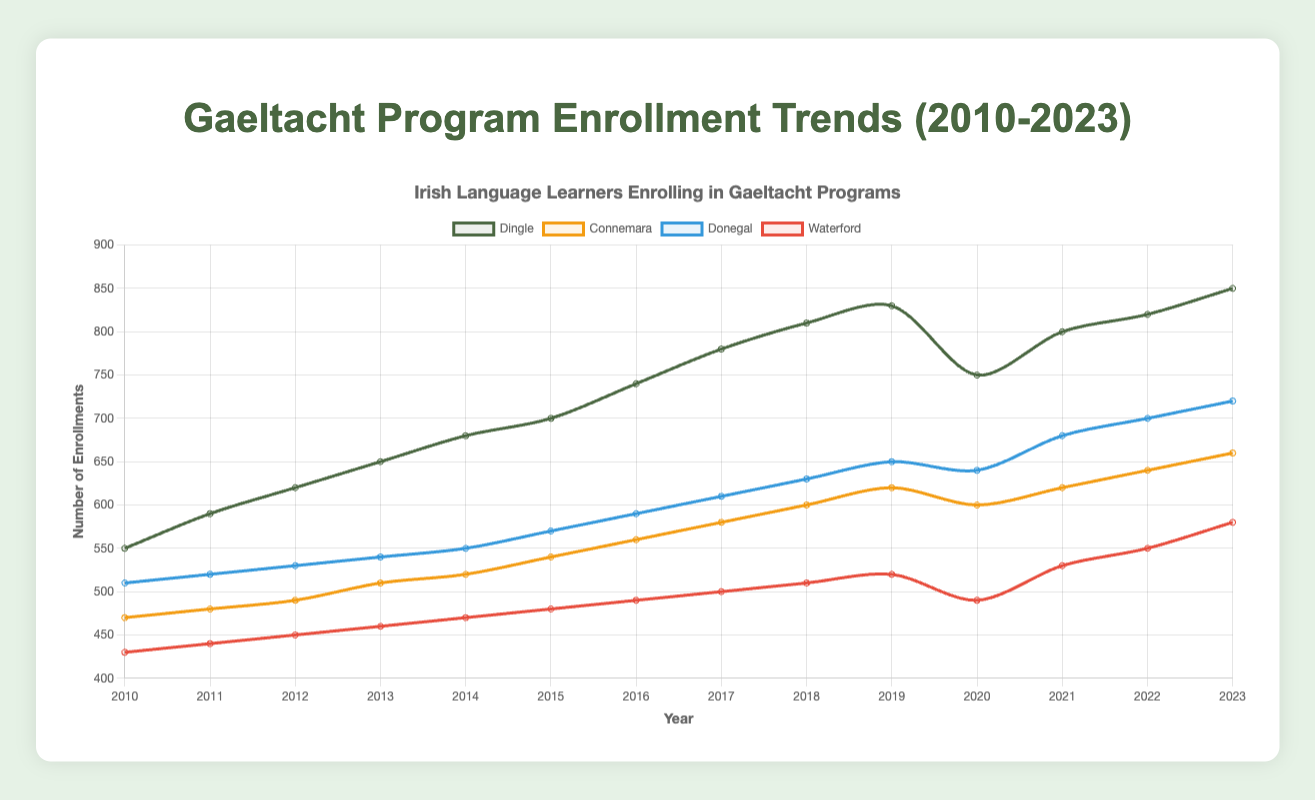What's the overall trend for the number of enrollments in Dingle from 2010 to 2023? The number of enrollments in Dingle starts at 550 in 2010 and increases steadily every year, reaching a peak of 850 in 2023. This shows a clear upward trend over the period.
Answer: Upward trend Which year had the highest number of enrollments in Donegal? By observing the line representing Donegal, it reaches its highest point in 2023 with 720 enrollments.
Answer: 2023 How do the number of enrollments in Waterford in 2010 and 2023 compare? The number of enrollments in Waterford in 2010 was 430, whereas in 2023, it was 580. To get the difference, subtract 430 from 580: 580 - 430 = 150.
Answer: Waterford enrollments increased by 150 What is the average number of enrollments in Connemara between 2010 and 2023? Sum the number of enrollments for Connemara and divide by the number of years: (470 + 480 + 490 + 510 + 520 + 540 + 560 + 580 + 600 + 620 + 600 + 620 + 640 + 660) / 14 = 7180 / 14 = 512.86.
Answer: 512.86 Which location showed the greatest increase in enrollments from 2010 to 2023? Calculate the increase for each location by subtracting the enrollments in 2010 from those in 2023: Dingle (850-550=300), Connemara (660-470=190), Donegal (720-510=210), and Waterford (580-430=150).
Answer: Dingle (300) Does Donegal ever have fewer enrollments than Connemara between 2010 and 2023? If so, when? Compare the values of Donegal and Connemara each year. Donegal has fewer enrollments than Connemara in the years 2010 (510 < 470), 2011 (520 < 480), 2012 (530 < 490), and 2013 (540 < 510).
Answer: 2010, 2011, 2012, 2013 In which year did enrollments in Dingle and Waterford diverge the most? Calculate the absolute differences between Dingle and Waterford each year and identify the year with the highest difference. The highest difference is in 2020:
Answer: 2020 (750 - 490 = 260) How did enrollments change in 2020 compared to 2019 across all locations? Subtract 2019 enrollments from 2020 enrollments for each location: Dingle (750-830=-80), Connemara (600-620=-20), Donegal (640-650=-10), Waterford (490-520=-30). All locations saw a drop in enrollments.
Answer: Decreased for all Which location's enrollment numbers remained the most stable over the years? Calculate the difference between the highest and lowest enrollments for each location. The smallest range indicates stability. Differences: Dingle (850-550=300), Connemara (660-470=190), Donegal (720-510=210), Waterford (580-430=150).
Answer: Waterford (150) What is the total increase in enrollments across all locales from 2010 to 2023? Sum the increases from 2010 to 2023 for each location: Dingle (300), Connemara (190), Donegal (210), Waterford (150). The total increase is 300 + 190 + 210 + 150 = 850.
Answer: 850 